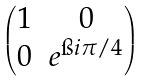<formula> <loc_0><loc_0><loc_500><loc_500>\begin{pmatrix} 1 & 0 \\ 0 & e ^ { \i i \pi / 4 } \end{pmatrix}</formula> 